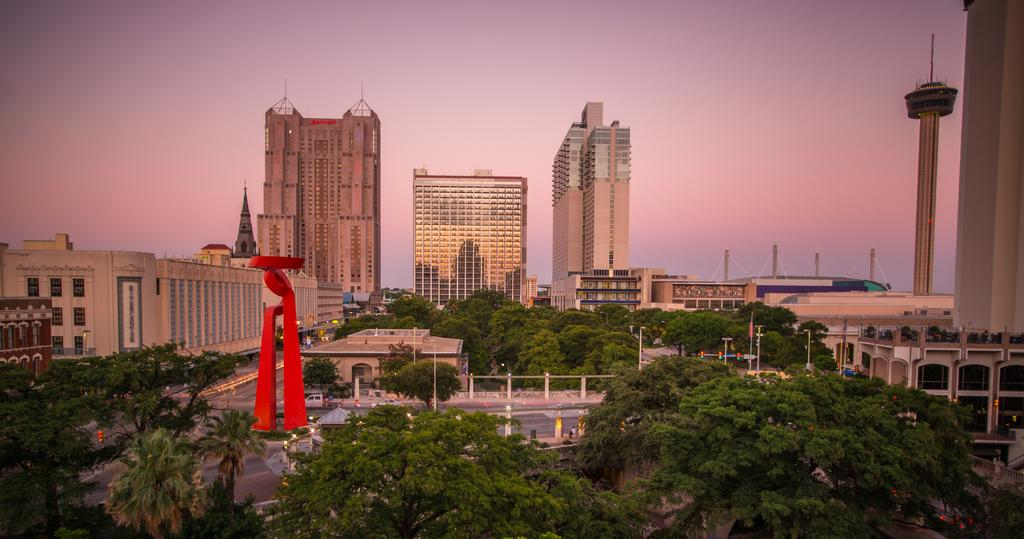What type of structures can be seen in the image? There are buildings in the image. What other natural elements are present in the image? There are trees in the image. What object can be seen standing upright in the image? There is a pole in the image. What can be used for illumination in the image? There are lights in the image. What type of transportation is visible in the image? There are vehicles in the image. What type of pathway is present in the image? There is a road in the image. What architectural feature can be seen in the image? There is an arch in the image. What part of the natural environment is visible in the image? The sky is visible in the image. How does the afterthought affect the digestion of the vehicles in the image? There is no mention of an afterthought or digestion in the image, as it features buildings, trees, a pole, lights, vehicles, a road, an arch, and the sky. Can you describe the kick of the pole in the image? There is no kick or movement of the pole in the image; it is stationary and upright. 